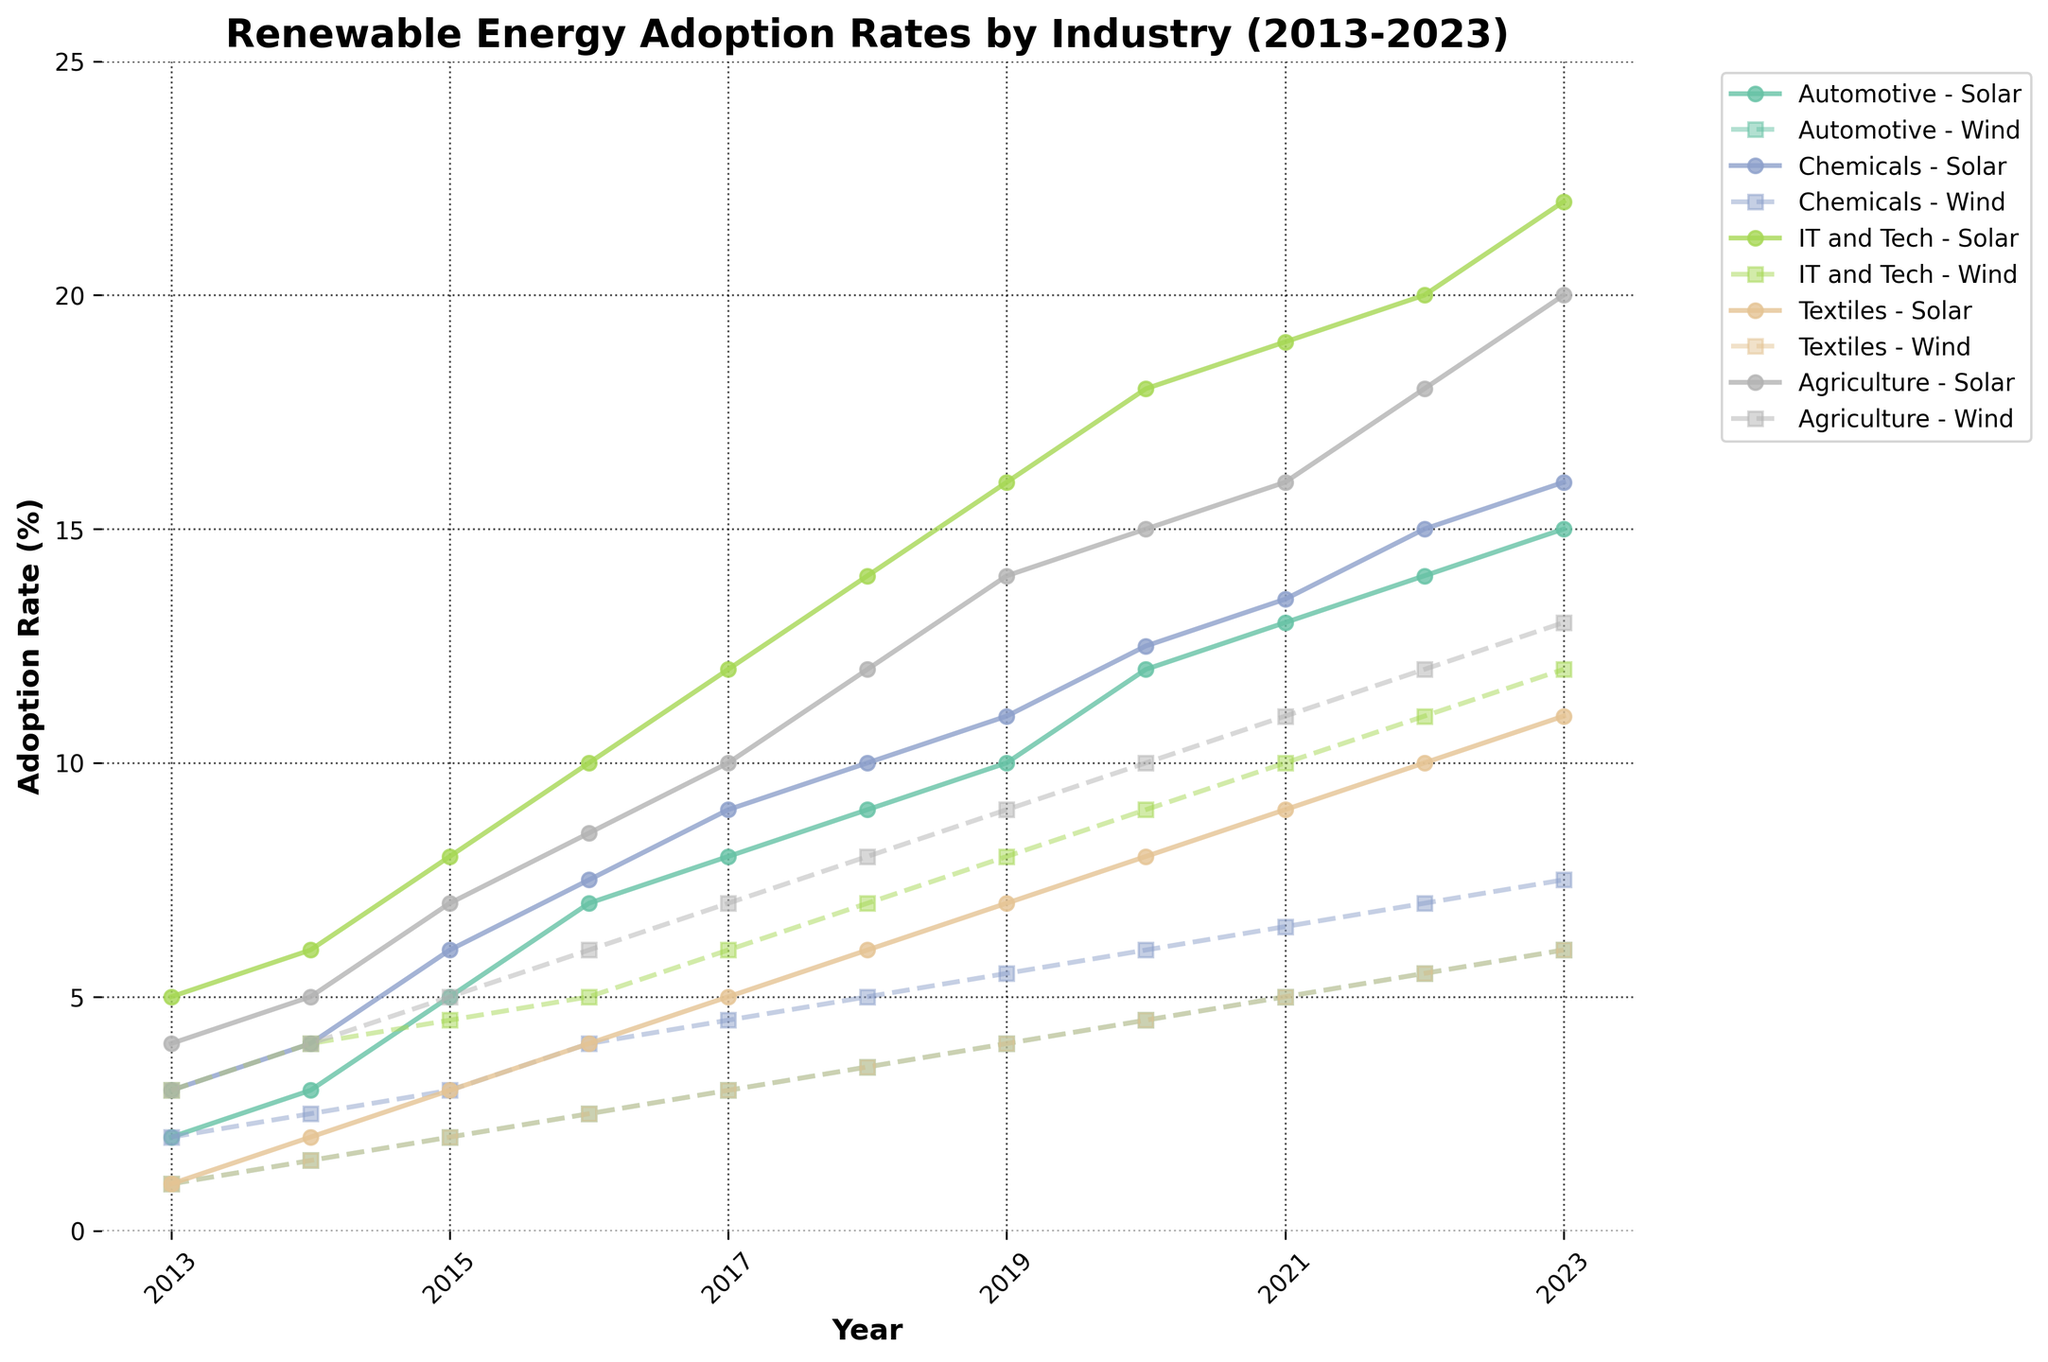How many industries are represented in the figure? The title "Renewable Energy Adoption Rates by Industry (2013-2023)" suggests that multiple industries are represented. Reviewing the plot legend, I count the number of distinct industries.
Answer: 5 What is the title of the figure? The title is shown at the top center of the figure and provides a wider context for interpreting the data.
Answer: Renewable Energy Adoption Rates by Industry (2013-2023) Which industry saw the highest Solar Energy adoption rate in 2023? To determine this, I look at the lines representing Solar Energy for each industry and find the peak value for 2023. Specifically, I note the highest point on the corresponding line for solar energy in 2023.
Answer: IT and Tech What is the wind energy adoption rate for the Agriculture industry in 2017? On the plot, I find the line representing wind energy for the Agriculture industry, then locate the value corresponding to the year 2017.
Answer: 7% Between 2013 and 2023, which industry showed the most significant increase in solar energy adoption? I compare the solar energy adoption rates for each industry between 2013 and 2023. By calculating the difference for each industry, the one with the largest increase is identified.
Answer: IT and Tech Compare the Solar and Wind energy adoption rates in the Chemicals industry in 2015. Which one is higher? I look at the specific points for Solar and Wind energy adoption rates in 2015 for the Chemicals industry and compare their heights.
Answer: Solar In which year did the IT and Tech industry first reach a solar energy adoption rate of 10% or more? To answer this, I track the solar energy line for the IT and Tech industry until its corresponding y-axis value reaches or exceeds 10%.
Answer: 2016 Which industry had the lowest wind energy adoption rate in 2022? By comparing the values of wind energy adoption rates for each industry in 2022, I identify the industry with the lowest rate.
Answer: Textiles What is the average solar energy adoption rate for the Automotive industry across all years displayed? I sum all the solar energy adoption rates for the Automotive industry and divide by the number of years (11) to find the mean value. The data points are: 2, 3, 5, 7, 8, 9, 10, 12, 13, 14, 15. The calculation is (2+3+5+7+8+9+10+12+13+14+15)/11.
Answer: 8.45% Which industry saw the smallest overall increase in wind energy adoption between 2013 and 2023? By subtracting the wind energy adoption rate in 2013 from the rate in 2023 for every industry, the industry with the least increase can be identified. The data points are: Automotive (6-1), Chemicals (7.5-2), IT and Tech (12-3), Textiles (6-1), Agriculture (13-3).
Answer: Automotive 